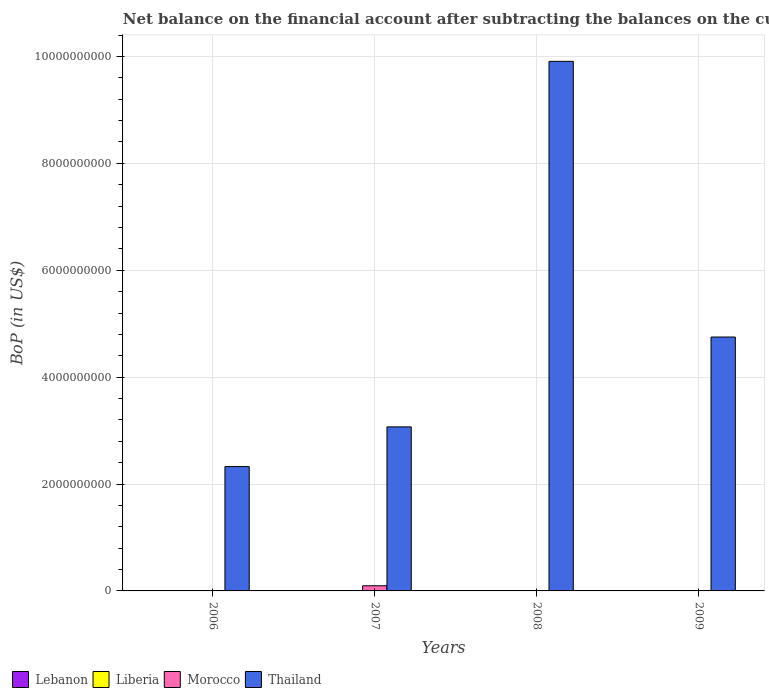In how many cases, is the number of bars for a given year not equal to the number of legend labels?
Offer a very short reply. 4. What is the Balance of Payments in Thailand in 2007?
Your response must be concise. 3.07e+09. Across all years, what is the maximum Balance of Payments in Morocco?
Your answer should be very brief. 9.64e+07. What is the total Balance of Payments in Lebanon in the graph?
Your response must be concise. 0. What is the difference between the Balance of Payments in Thailand in 2007 and the Balance of Payments in Lebanon in 2008?
Your answer should be very brief. 3.07e+09. In the year 2007, what is the difference between the Balance of Payments in Morocco and Balance of Payments in Thailand?
Provide a short and direct response. -2.97e+09. What is the ratio of the Balance of Payments in Thailand in 2007 to that in 2008?
Provide a succinct answer. 0.31. Is the Balance of Payments in Thailand in 2007 less than that in 2009?
Offer a very short reply. Yes. What is the difference between the highest and the second highest Balance of Payments in Thailand?
Your answer should be very brief. 5.16e+09. What is the difference between the highest and the lowest Balance of Payments in Morocco?
Provide a succinct answer. 9.64e+07. In how many years, is the Balance of Payments in Liberia greater than the average Balance of Payments in Liberia taken over all years?
Your answer should be very brief. 0. Is it the case that in every year, the sum of the Balance of Payments in Thailand and Balance of Payments in Lebanon is greater than the Balance of Payments in Liberia?
Ensure brevity in your answer.  Yes. Are all the bars in the graph horizontal?
Make the answer very short. No. What is the title of the graph?
Your response must be concise. Net balance on the financial account after subtracting the balances on the current accounts. Does "Cambodia" appear as one of the legend labels in the graph?
Offer a very short reply. No. What is the label or title of the Y-axis?
Ensure brevity in your answer.  BoP (in US$). What is the BoP (in US$) of Lebanon in 2006?
Make the answer very short. 0. What is the BoP (in US$) of Liberia in 2006?
Give a very brief answer. 0. What is the BoP (in US$) of Thailand in 2006?
Make the answer very short. 2.33e+09. What is the BoP (in US$) in Morocco in 2007?
Offer a very short reply. 9.64e+07. What is the BoP (in US$) of Thailand in 2007?
Your answer should be compact. 3.07e+09. What is the BoP (in US$) in Morocco in 2008?
Make the answer very short. 0. What is the BoP (in US$) in Thailand in 2008?
Provide a succinct answer. 9.91e+09. What is the BoP (in US$) of Thailand in 2009?
Make the answer very short. 4.75e+09. Across all years, what is the maximum BoP (in US$) of Morocco?
Provide a succinct answer. 9.64e+07. Across all years, what is the maximum BoP (in US$) in Thailand?
Ensure brevity in your answer.  9.91e+09. Across all years, what is the minimum BoP (in US$) in Thailand?
Provide a succinct answer. 2.33e+09. What is the total BoP (in US$) in Lebanon in the graph?
Keep it short and to the point. 0. What is the total BoP (in US$) in Liberia in the graph?
Offer a very short reply. 0. What is the total BoP (in US$) in Morocco in the graph?
Offer a very short reply. 9.64e+07. What is the total BoP (in US$) of Thailand in the graph?
Your answer should be compact. 2.01e+1. What is the difference between the BoP (in US$) in Thailand in 2006 and that in 2007?
Keep it short and to the point. -7.42e+08. What is the difference between the BoP (in US$) in Thailand in 2006 and that in 2008?
Keep it short and to the point. -7.58e+09. What is the difference between the BoP (in US$) in Thailand in 2006 and that in 2009?
Ensure brevity in your answer.  -2.42e+09. What is the difference between the BoP (in US$) of Thailand in 2007 and that in 2008?
Offer a terse response. -6.84e+09. What is the difference between the BoP (in US$) in Thailand in 2007 and that in 2009?
Your answer should be compact. -1.68e+09. What is the difference between the BoP (in US$) of Thailand in 2008 and that in 2009?
Provide a short and direct response. 5.16e+09. What is the difference between the BoP (in US$) of Morocco in 2007 and the BoP (in US$) of Thailand in 2008?
Offer a terse response. -9.81e+09. What is the difference between the BoP (in US$) of Morocco in 2007 and the BoP (in US$) of Thailand in 2009?
Offer a terse response. -4.65e+09. What is the average BoP (in US$) of Lebanon per year?
Provide a succinct answer. 0. What is the average BoP (in US$) of Liberia per year?
Give a very brief answer. 0. What is the average BoP (in US$) of Morocco per year?
Your response must be concise. 2.41e+07. What is the average BoP (in US$) of Thailand per year?
Your response must be concise. 5.01e+09. In the year 2007, what is the difference between the BoP (in US$) of Morocco and BoP (in US$) of Thailand?
Give a very brief answer. -2.97e+09. What is the ratio of the BoP (in US$) of Thailand in 2006 to that in 2007?
Provide a short and direct response. 0.76. What is the ratio of the BoP (in US$) of Thailand in 2006 to that in 2008?
Provide a succinct answer. 0.23. What is the ratio of the BoP (in US$) of Thailand in 2006 to that in 2009?
Offer a terse response. 0.49. What is the ratio of the BoP (in US$) of Thailand in 2007 to that in 2008?
Make the answer very short. 0.31. What is the ratio of the BoP (in US$) of Thailand in 2007 to that in 2009?
Provide a short and direct response. 0.65. What is the ratio of the BoP (in US$) in Thailand in 2008 to that in 2009?
Provide a succinct answer. 2.09. What is the difference between the highest and the second highest BoP (in US$) in Thailand?
Give a very brief answer. 5.16e+09. What is the difference between the highest and the lowest BoP (in US$) of Morocco?
Give a very brief answer. 9.64e+07. What is the difference between the highest and the lowest BoP (in US$) in Thailand?
Your answer should be very brief. 7.58e+09. 